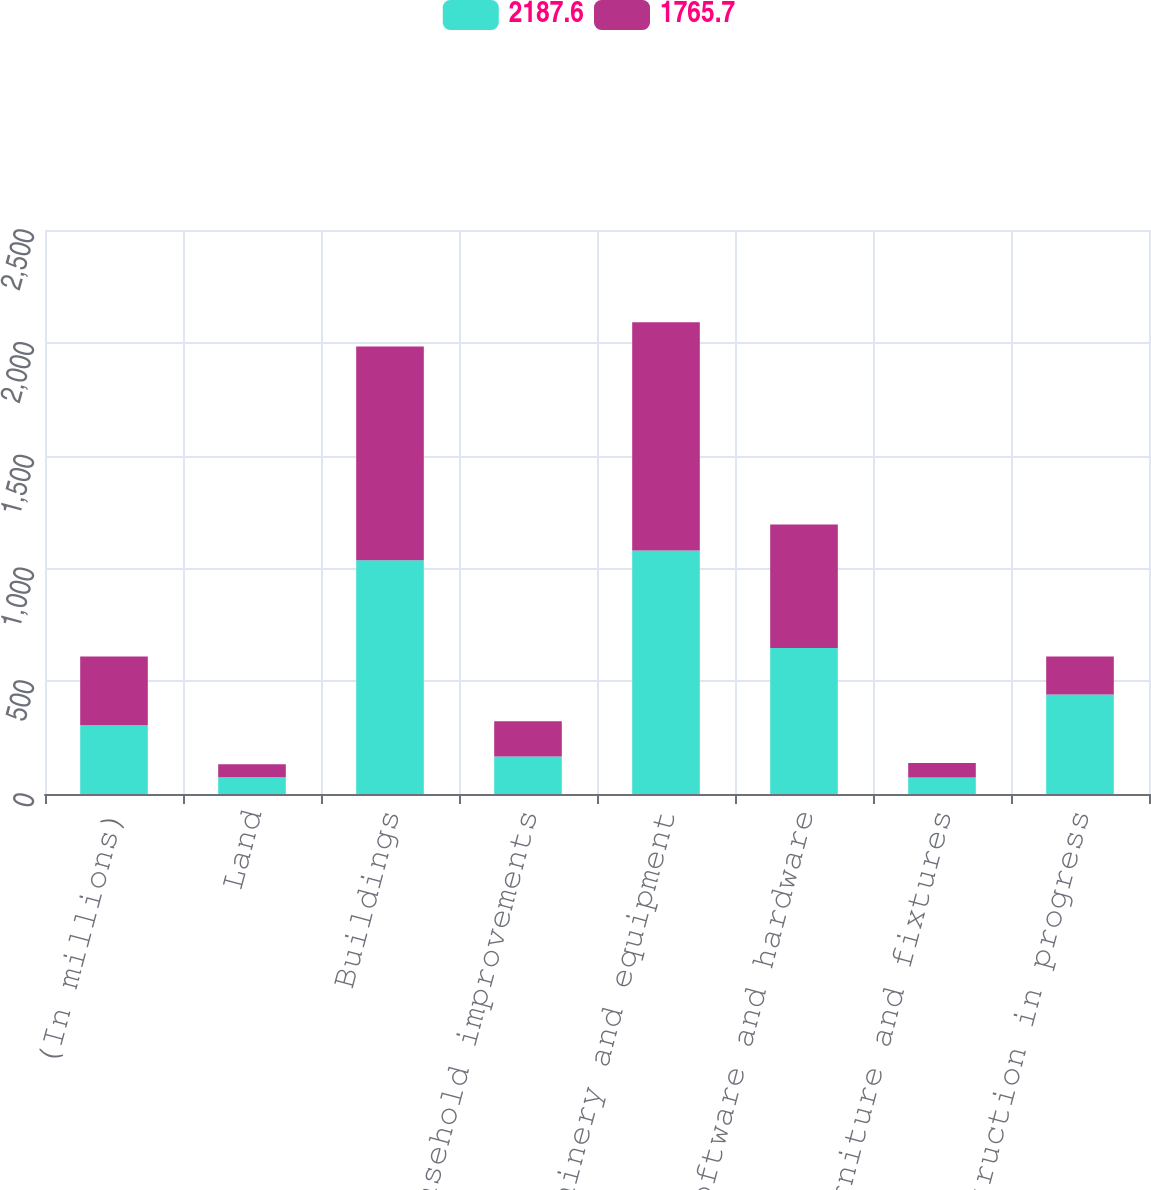Convert chart to OTSL. <chart><loc_0><loc_0><loc_500><loc_500><stacked_bar_chart><ecel><fcel>(In millions)<fcel>Land<fcel>Buildings<fcel>Leasehold improvements<fcel>Machinery and equipment<fcel>Computer software and hardware<fcel>Furniture and fixtures<fcel>Construction in progress<nl><fcel>2187.6<fcel>304.9<fcel>74.7<fcel>1035.6<fcel>166.6<fcel>1079.6<fcel>647.1<fcel>72.9<fcel>441.2<nl><fcel>1765.7<fcel>304.9<fcel>56.9<fcel>947.7<fcel>155.5<fcel>1011.3<fcel>547.8<fcel>64.3<fcel>168.6<nl></chart> 